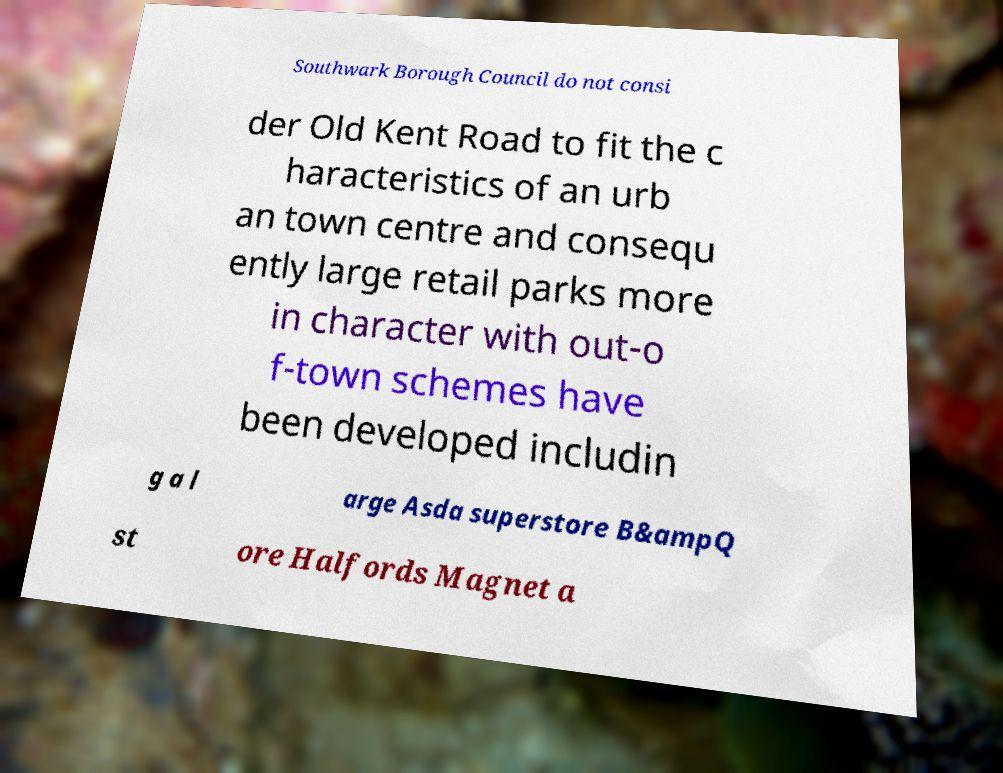Can you read and provide the text displayed in the image?This photo seems to have some interesting text. Can you extract and type it out for me? Southwark Borough Council do not consi der Old Kent Road to fit the c haracteristics of an urb an town centre and consequ ently large retail parks more in character with out-o f-town schemes have been developed includin g a l arge Asda superstore B&ampQ st ore Halfords Magnet a 